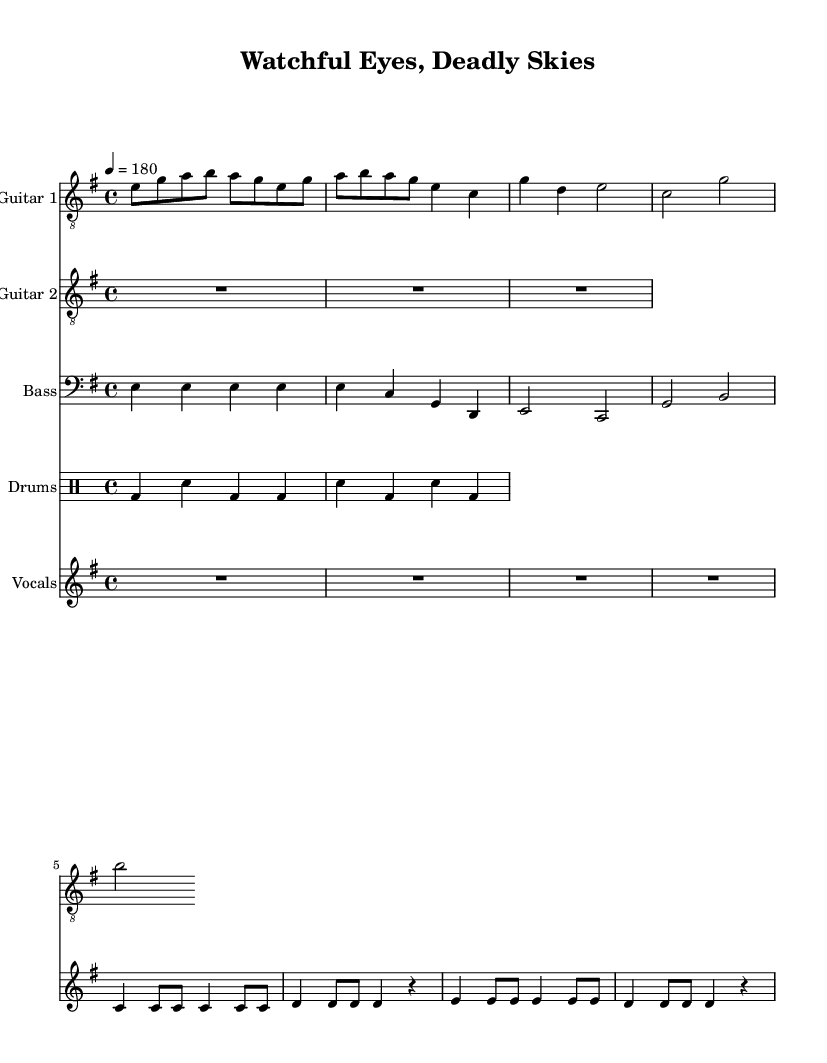What is the key signature of this music? The key signature is E minor, which is indicated by one sharp (F#) in the key signature area at the beginning of the staff.
Answer: E minor What is the time signature of this music? The time signature is 4/4, which is indicated by the "4 over 4" at the beginning of the piece, meaning there are four beats in each measure and the quarter note gets one beat.
Answer: 4/4 What is the tempo marking for this piece? The tempo marking is given as 4 = 180, meaning there are 180 beats per minute, suggesting a very fast and aggressive pace typical of thrash metal.
Answer: 180 How many measures does the verse section contain? To determine this, review the verse section in the notation; it consists of three measures. This is based on the number of distinct sets of rhythms that extend across the staff for that section.
Answer: 3 What type of drum pattern is used in this piece? The drum pattern is a standard rock beat, with bass drum (bd) and snare drum (sn) alternately played, a common feature in thrash metal to maintain high energy and drive.
Answer: Rock beat What theme is reflected in the lyrics? The theme reflected in the lyrics focuses on government surveillance and military interventions, as described through the imagery of "Watchful eyes" and "Robotic death." This aligns with the socio-political critique often prevalent in thrash metal.
Answer: Government surveillance Which instrument plays the main riff? The main riff is played by Guitar 1, as indicated by the music notation showcasing notes that capture the essence of the song’s aggressive style typical of metal.
Answer: Guitar 1 